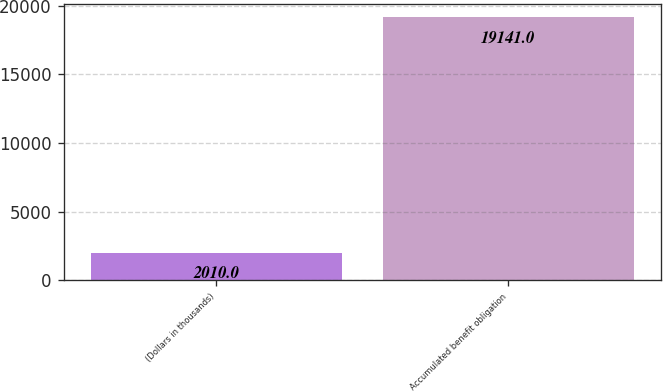<chart> <loc_0><loc_0><loc_500><loc_500><bar_chart><fcel>(Dollars in thousands)<fcel>Accumulated benefit obligation<nl><fcel>2010<fcel>19141<nl></chart> 